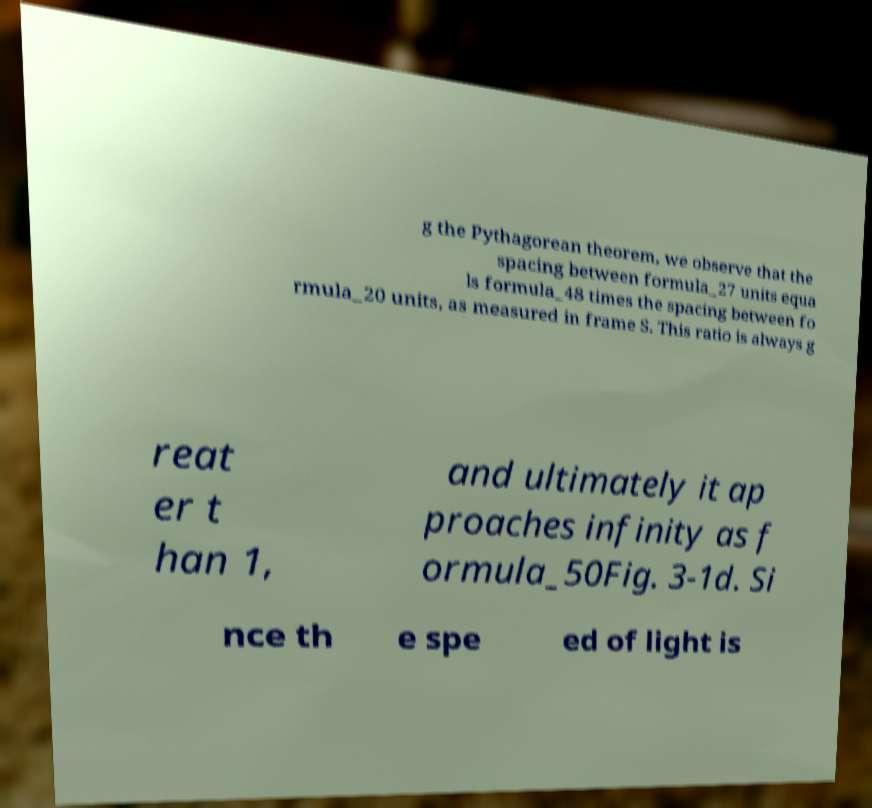I need the written content from this picture converted into text. Can you do that? g the Pythagorean theorem, we observe that the spacing between formula_27 units equa ls formula_48 times the spacing between fo rmula_20 units, as measured in frame S. This ratio is always g reat er t han 1, and ultimately it ap proaches infinity as f ormula_50Fig. 3-1d. Si nce th e spe ed of light is 